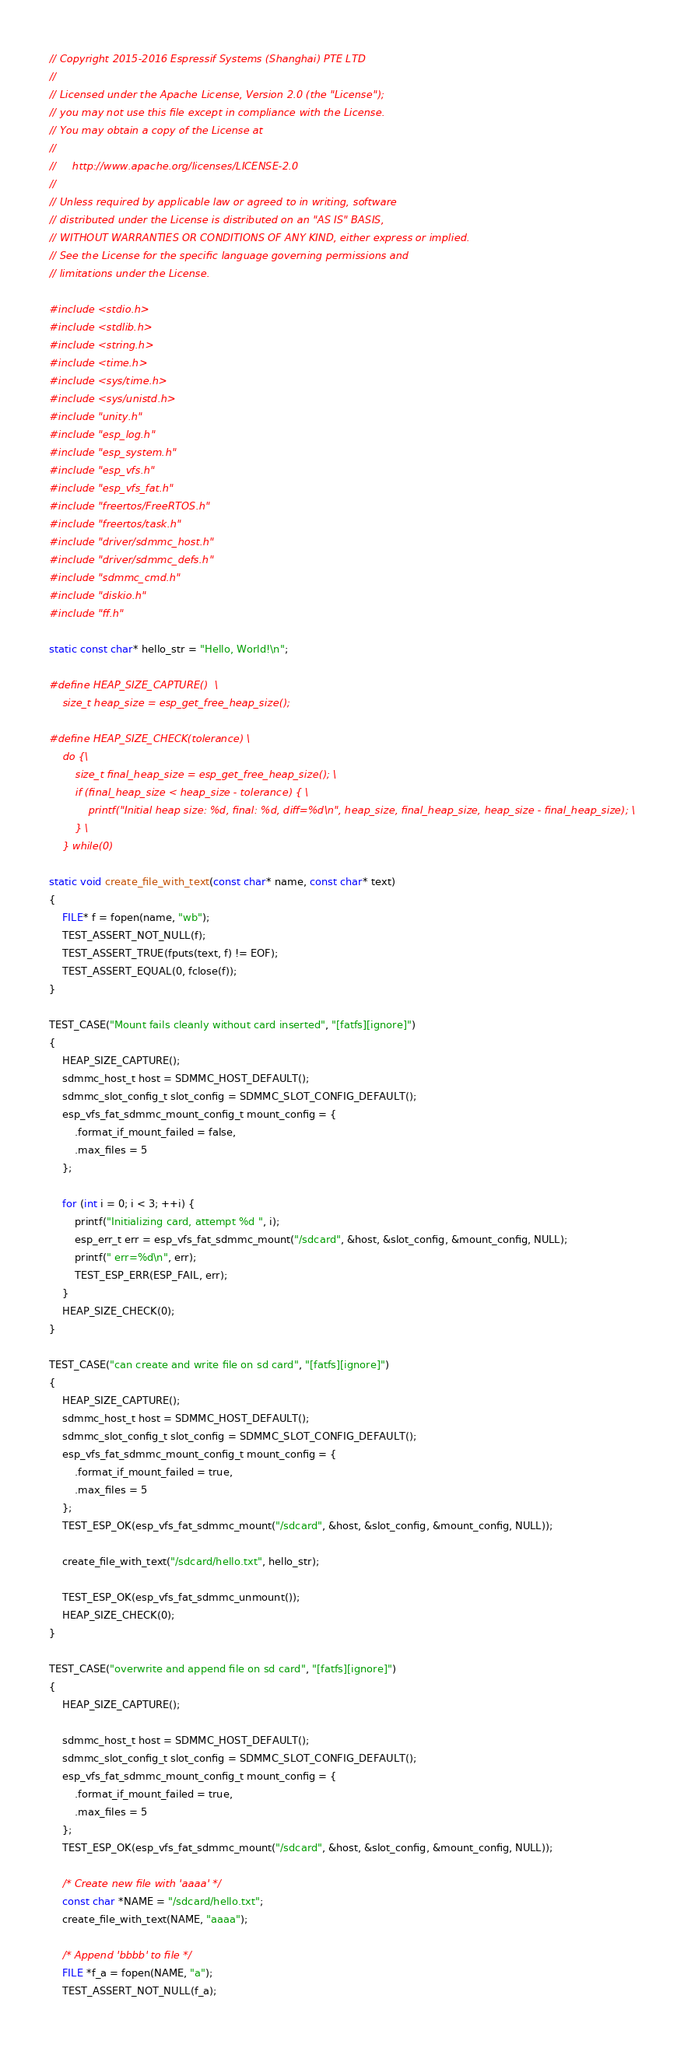<code> <loc_0><loc_0><loc_500><loc_500><_C_>// Copyright 2015-2016 Espressif Systems (Shanghai) PTE LTD
//
// Licensed under the Apache License, Version 2.0 (the "License");
// you may not use this file except in compliance with the License.
// You may obtain a copy of the License at
//
//     http://www.apache.org/licenses/LICENSE-2.0
//
// Unless required by applicable law or agreed to in writing, software
// distributed under the License is distributed on an "AS IS" BASIS,
// WITHOUT WARRANTIES OR CONDITIONS OF ANY KIND, either express or implied.
// See the License for the specific language governing permissions and
// limitations under the License.

#include <stdio.h>
#include <stdlib.h>
#include <string.h>
#include <time.h>
#include <sys/time.h>
#include <sys/unistd.h>
#include "unity.h"
#include "esp_log.h"
#include "esp_system.h"
#include "esp_vfs.h"
#include "esp_vfs_fat.h"
#include "freertos/FreeRTOS.h"
#include "freertos/task.h"
#include "driver/sdmmc_host.h"
#include "driver/sdmmc_defs.h"
#include "sdmmc_cmd.h"
#include "diskio.h"
#include "ff.h"

static const char* hello_str = "Hello, World!\n";

#define HEAP_SIZE_CAPTURE()  \
    size_t heap_size = esp_get_free_heap_size();

#define HEAP_SIZE_CHECK(tolerance) \
    do {\
        size_t final_heap_size = esp_get_free_heap_size(); \
        if (final_heap_size < heap_size - tolerance) { \
            printf("Initial heap size: %d, final: %d, diff=%d\n", heap_size, final_heap_size, heap_size - final_heap_size); \
        } \
    } while(0)

static void create_file_with_text(const char* name, const char* text)
{
    FILE* f = fopen(name, "wb");
    TEST_ASSERT_NOT_NULL(f);
    TEST_ASSERT_TRUE(fputs(text, f) != EOF);
    TEST_ASSERT_EQUAL(0, fclose(f));
}

TEST_CASE("Mount fails cleanly without card inserted", "[fatfs][ignore]")
{
    HEAP_SIZE_CAPTURE();
    sdmmc_host_t host = SDMMC_HOST_DEFAULT();
    sdmmc_slot_config_t slot_config = SDMMC_SLOT_CONFIG_DEFAULT();
    esp_vfs_fat_sdmmc_mount_config_t mount_config = {
        .format_if_mount_failed = false,
        .max_files = 5
    };

    for (int i = 0; i < 3; ++i) {
        printf("Initializing card, attempt %d ", i);
        esp_err_t err = esp_vfs_fat_sdmmc_mount("/sdcard", &host, &slot_config, &mount_config, NULL);
        printf(" err=%d\n", err);
        TEST_ESP_ERR(ESP_FAIL, err);
    }
    HEAP_SIZE_CHECK(0);
}

TEST_CASE("can create and write file on sd card", "[fatfs][ignore]")
{
    HEAP_SIZE_CAPTURE();
    sdmmc_host_t host = SDMMC_HOST_DEFAULT();
    sdmmc_slot_config_t slot_config = SDMMC_SLOT_CONFIG_DEFAULT();
    esp_vfs_fat_sdmmc_mount_config_t mount_config = {
        .format_if_mount_failed = true,
        .max_files = 5
    };
    TEST_ESP_OK(esp_vfs_fat_sdmmc_mount("/sdcard", &host, &slot_config, &mount_config, NULL));

    create_file_with_text("/sdcard/hello.txt", hello_str);

    TEST_ESP_OK(esp_vfs_fat_sdmmc_unmount());
    HEAP_SIZE_CHECK(0);
}

TEST_CASE("overwrite and append file on sd card", "[fatfs][ignore]")
{
    HEAP_SIZE_CAPTURE();

    sdmmc_host_t host = SDMMC_HOST_DEFAULT();
    sdmmc_slot_config_t slot_config = SDMMC_SLOT_CONFIG_DEFAULT();
    esp_vfs_fat_sdmmc_mount_config_t mount_config = {
        .format_if_mount_failed = true,
        .max_files = 5
    };
    TEST_ESP_OK(esp_vfs_fat_sdmmc_mount("/sdcard", &host, &slot_config, &mount_config, NULL));

    /* Create new file with 'aaaa' */
    const char *NAME = "/sdcard/hello.txt";
    create_file_with_text(NAME, "aaaa");

    /* Append 'bbbb' to file */
    FILE *f_a = fopen(NAME, "a");
    TEST_ASSERT_NOT_NULL(f_a);</code> 